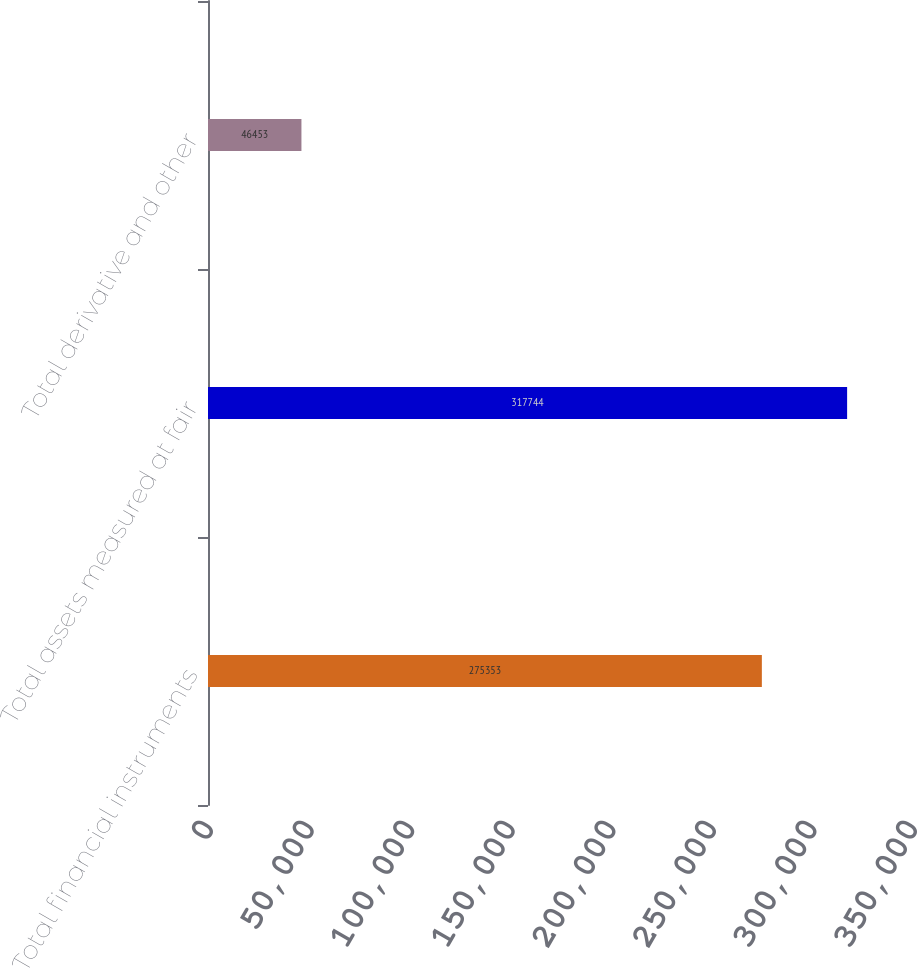Convert chart to OTSL. <chart><loc_0><loc_0><loc_500><loc_500><bar_chart><fcel>Total financial instruments<fcel>Total assets measured at fair<fcel>Total derivative and other<nl><fcel>275353<fcel>317744<fcel>46453<nl></chart> 